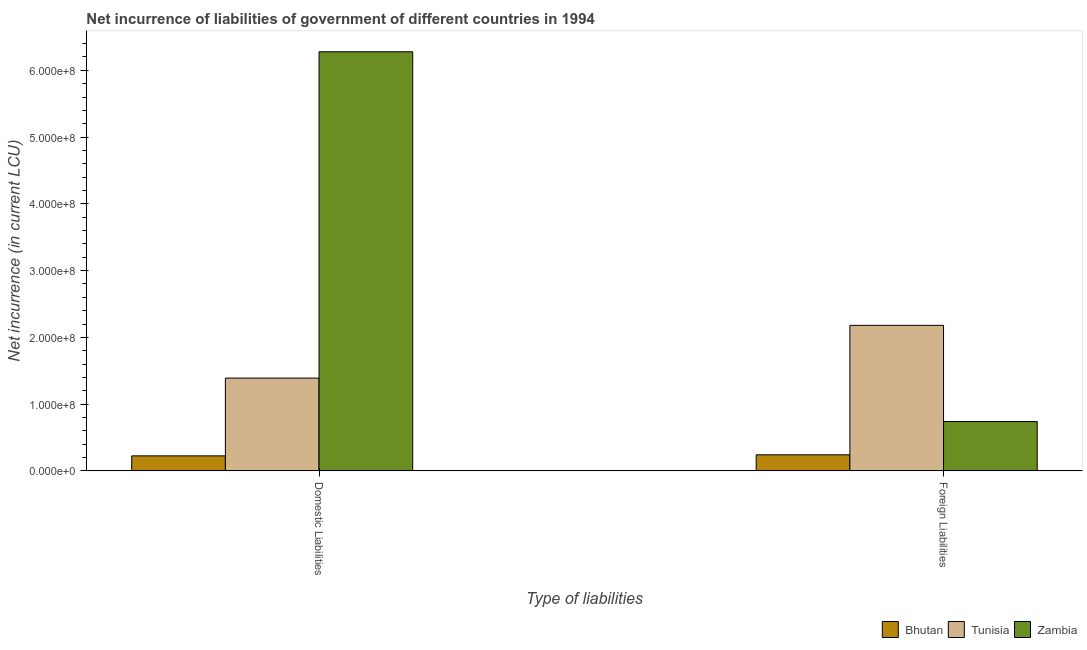How many different coloured bars are there?
Provide a succinct answer. 3. Are the number of bars on each tick of the X-axis equal?
Give a very brief answer. Yes. How many bars are there on the 1st tick from the right?
Your response must be concise. 3. What is the label of the 1st group of bars from the left?
Provide a succinct answer. Domestic Liabilities. What is the net incurrence of domestic liabilities in Zambia?
Your response must be concise. 6.28e+08. Across all countries, what is the maximum net incurrence of foreign liabilities?
Provide a succinct answer. 2.18e+08. Across all countries, what is the minimum net incurrence of foreign liabilities?
Offer a very short reply. 2.41e+07. In which country was the net incurrence of foreign liabilities maximum?
Give a very brief answer. Tunisia. In which country was the net incurrence of foreign liabilities minimum?
Keep it short and to the point. Bhutan. What is the total net incurrence of domestic liabilities in the graph?
Offer a very short reply. 7.89e+08. What is the difference between the net incurrence of foreign liabilities in Tunisia and that in Zambia?
Make the answer very short. 1.44e+08. What is the difference between the net incurrence of domestic liabilities in Bhutan and the net incurrence of foreign liabilities in Zambia?
Your response must be concise. -5.14e+07. What is the average net incurrence of foreign liabilities per country?
Keep it short and to the point. 1.05e+08. What is the difference between the net incurrence of foreign liabilities and net incurrence of domestic liabilities in Bhutan?
Your answer should be very brief. 1.60e+06. What is the ratio of the net incurrence of foreign liabilities in Tunisia to that in Bhutan?
Your response must be concise. 9.05. Is the net incurrence of domestic liabilities in Bhutan less than that in Tunisia?
Your answer should be very brief. Yes. In how many countries, is the net incurrence of foreign liabilities greater than the average net incurrence of foreign liabilities taken over all countries?
Your response must be concise. 1. What does the 2nd bar from the left in Domestic Liabilities represents?
Offer a very short reply. Tunisia. What does the 1st bar from the right in Domestic Liabilities represents?
Make the answer very short. Zambia. How many bars are there?
Your response must be concise. 6. Are all the bars in the graph horizontal?
Your response must be concise. No. How many countries are there in the graph?
Provide a short and direct response. 3. Are the values on the major ticks of Y-axis written in scientific E-notation?
Your answer should be very brief. Yes. How many legend labels are there?
Keep it short and to the point. 3. How are the legend labels stacked?
Give a very brief answer. Horizontal. What is the title of the graph?
Ensure brevity in your answer.  Net incurrence of liabilities of government of different countries in 1994. Does "China" appear as one of the legend labels in the graph?
Your response must be concise. No. What is the label or title of the X-axis?
Keep it short and to the point. Type of liabilities. What is the label or title of the Y-axis?
Keep it short and to the point. Net incurrence (in current LCU). What is the Net incurrence (in current LCU) in Bhutan in Domestic Liabilities?
Offer a terse response. 2.25e+07. What is the Net incurrence (in current LCU) of Tunisia in Domestic Liabilities?
Your answer should be very brief. 1.39e+08. What is the Net incurrence (in current LCU) in Zambia in Domestic Liabilities?
Your response must be concise. 6.28e+08. What is the Net incurrence (in current LCU) in Bhutan in Foreign Liabilities?
Your answer should be compact. 2.41e+07. What is the Net incurrence (in current LCU) of Tunisia in Foreign Liabilities?
Offer a terse response. 2.18e+08. What is the Net incurrence (in current LCU) of Zambia in Foreign Liabilities?
Your answer should be compact. 7.39e+07. Across all Type of liabilities, what is the maximum Net incurrence (in current LCU) of Bhutan?
Offer a very short reply. 2.41e+07. Across all Type of liabilities, what is the maximum Net incurrence (in current LCU) in Tunisia?
Provide a succinct answer. 2.18e+08. Across all Type of liabilities, what is the maximum Net incurrence (in current LCU) of Zambia?
Ensure brevity in your answer.  6.28e+08. Across all Type of liabilities, what is the minimum Net incurrence (in current LCU) in Bhutan?
Ensure brevity in your answer.  2.25e+07. Across all Type of liabilities, what is the minimum Net incurrence (in current LCU) of Tunisia?
Your answer should be very brief. 1.39e+08. Across all Type of liabilities, what is the minimum Net incurrence (in current LCU) in Zambia?
Your answer should be very brief. 7.39e+07. What is the total Net incurrence (in current LCU) in Bhutan in the graph?
Your response must be concise. 4.66e+07. What is the total Net incurrence (in current LCU) in Tunisia in the graph?
Your response must be concise. 3.57e+08. What is the total Net incurrence (in current LCU) in Zambia in the graph?
Your answer should be very brief. 7.02e+08. What is the difference between the Net incurrence (in current LCU) of Bhutan in Domestic Liabilities and that in Foreign Liabilities?
Your answer should be compact. -1.60e+06. What is the difference between the Net incurrence (in current LCU) in Tunisia in Domestic Liabilities and that in Foreign Liabilities?
Keep it short and to the point. -7.90e+07. What is the difference between the Net incurrence (in current LCU) in Zambia in Domestic Liabilities and that in Foreign Liabilities?
Offer a terse response. 5.54e+08. What is the difference between the Net incurrence (in current LCU) of Bhutan in Domestic Liabilities and the Net incurrence (in current LCU) of Tunisia in Foreign Liabilities?
Your answer should be compact. -1.96e+08. What is the difference between the Net incurrence (in current LCU) in Bhutan in Domestic Liabilities and the Net incurrence (in current LCU) in Zambia in Foreign Liabilities?
Keep it short and to the point. -5.14e+07. What is the difference between the Net incurrence (in current LCU) in Tunisia in Domestic Liabilities and the Net incurrence (in current LCU) in Zambia in Foreign Liabilities?
Your response must be concise. 6.51e+07. What is the average Net incurrence (in current LCU) in Bhutan per Type of liabilities?
Provide a succinct answer. 2.33e+07. What is the average Net incurrence (in current LCU) in Tunisia per Type of liabilities?
Your answer should be very brief. 1.78e+08. What is the average Net incurrence (in current LCU) in Zambia per Type of liabilities?
Your answer should be very brief. 3.51e+08. What is the difference between the Net incurrence (in current LCU) of Bhutan and Net incurrence (in current LCU) of Tunisia in Domestic Liabilities?
Your answer should be very brief. -1.16e+08. What is the difference between the Net incurrence (in current LCU) of Bhutan and Net incurrence (in current LCU) of Zambia in Domestic Liabilities?
Ensure brevity in your answer.  -6.05e+08. What is the difference between the Net incurrence (in current LCU) of Tunisia and Net incurrence (in current LCU) of Zambia in Domestic Liabilities?
Ensure brevity in your answer.  -4.89e+08. What is the difference between the Net incurrence (in current LCU) of Bhutan and Net incurrence (in current LCU) of Tunisia in Foreign Liabilities?
Keep it short and to the point. -1.94e+08. What is the difference between the Net incurrence (in current LCU) in Bhutan and Net incurrence (in current LCU) in Zambia in Foreign Liabilities?
Offer a terse response. -4.98e+07. What is the difference between the Net incurrence (in current LCU) in Tunisia and Net incurrence (in current LCU) in Zambia in Foreign Liabilities?
Your response must be concise. 1.44e+08. What is the ratio of the Net incurrence (in current LCU) in Bhutan in Domestic Liabilities to that in Foreign Liabilities?
Offer a terse response. 0.93. What is the ratio of the Net incurrence (in current LCU) in Tunisia in Domestic Liabilities to that in Foreign Liabilities?
Provide a succinct answer. 0.64. What is the ratio of the Net incurrence (in current LCU) in Zambia in Domestic Liabilities to that in Foreign Liabilities?
Your answer should be compact. 8.5. What is the difference between the highest and the second highest Net incurrence (in current LCU) in Bhutan?
Offer a very short reply. 1.60e+06. What is the difference between the highest and the second highest Net incurrence (in current LCU) in Tunisia?
Make the answer very short. 7.90e+07. What is the difference between the highest and the second highest Net incurrence (in current LCU) of Zambia?
Keep it short and to the point. 5.54e+08. What is the difference between the highest and the lowest Net incurrence (in current LCU) in Bhutan?
Give a very brief answer. 1.60e+06. What is the difference between the highest and the lowest Net incurrence (in current LCU) of Tunisia?
Your answer should be very brief. 7.90e+07. What is the difference between the highest and the lowest Net incurrence (in current LCU) of Zambia?
Your answer should be compact. 5.54e+08. 